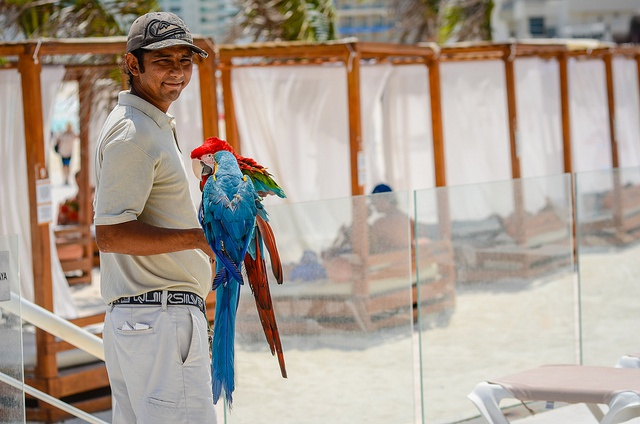Describe the objects in this image and their specific colors. I can see people in gray, darkgray, maroon, and brown tones, bird in gray, maroon, teal, and blue tones, bed in gray and darkgray tones, chair in gray, lightgray, and darkgray tones, and bed in gray, darkgray, tan, and lightgray tones in this image. 